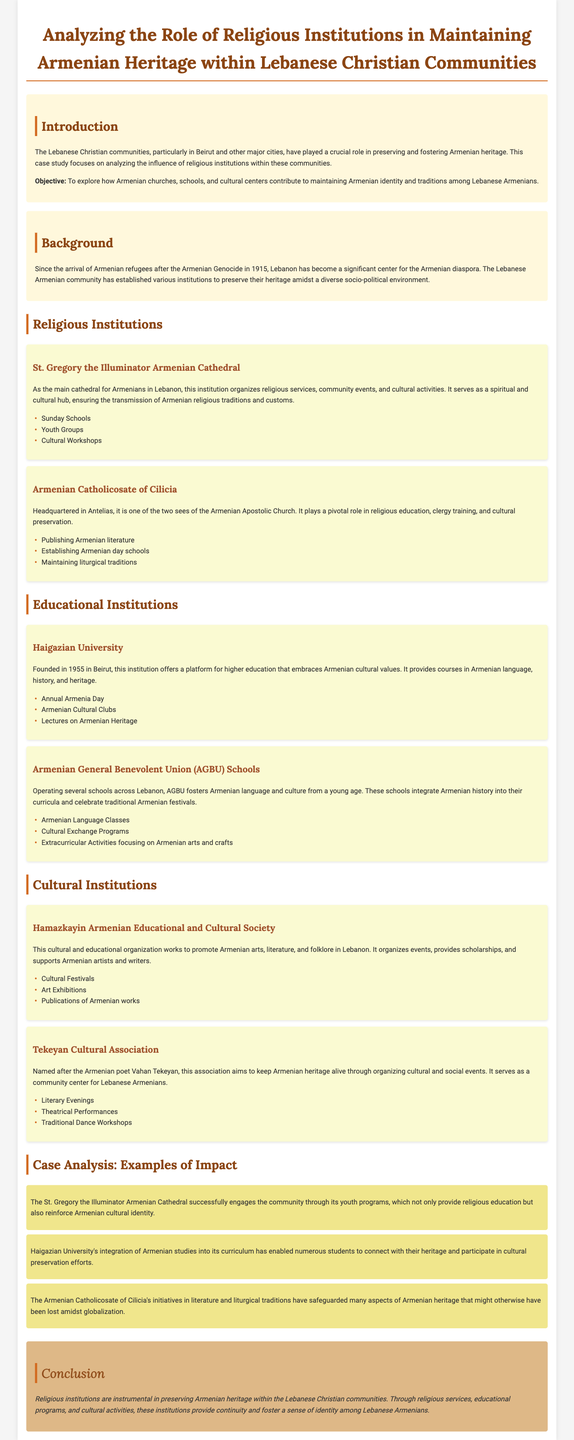what is the main cathedral for Armenians in Lebanon? The main cathedral mentioned in the document is St. Gregory the Illuminator Armenian Cathedral.
Answer: St. Gregory the Illuminator Armenian Cathedral when did Haigazian University get founded? The document specifies that Haigazian University was founded in 1955.
Answer: 1955 what role does the Armenian Catholicosate of Cilicia play? The document highlights its role in religious education, clergy training, and cultural preservation.
Answer: Religious education, clergy training, and cultural preservation name one activity organized by the Hamazkayin Armenian Educational and Cultural Society. One activity mentioned is the organization of cultural festivals.
Answer: Cultural Festivals how do AGBU schools contribute to Armenian culture? AGBU schools integrate Armenian history into their curricula and celebrate traditional Armenian festivals.
Answer: Integrate Armenian history into their curricula what impact do youth programs at St. Gregory Cathedral have? The youth programs engage the community and reinforce Armenian cultural identity.
Answer: Reinforce Armenian cultural identity which institution offers courses in Armenian language? The document states that Haigazian University offers courses in Armenian language.
Answer: Haigazian University what is a key aspect of the cultural activities offered by Tekeyan Cultural Association? The document mentions that it organizes traditional dance workshops.
Answer: Traditional dance workshops 